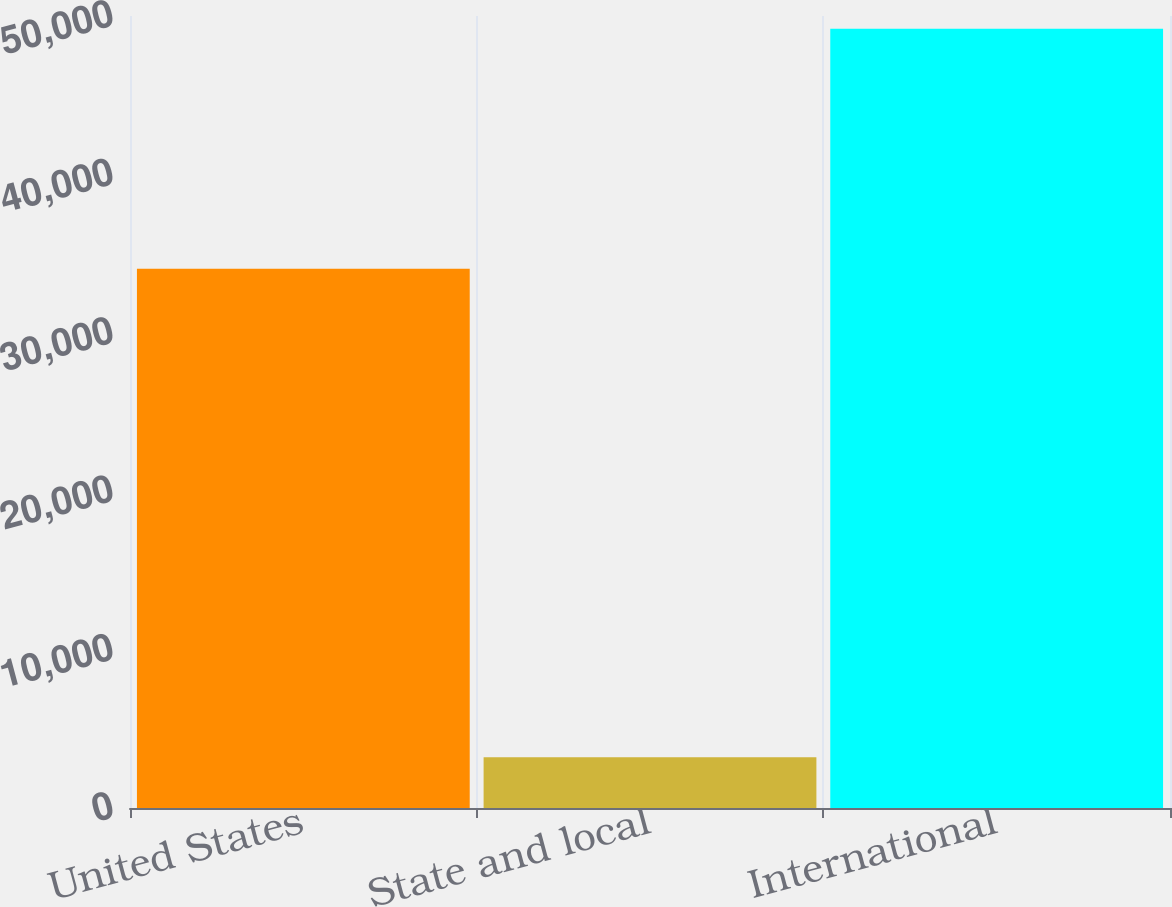Convert chart. <chart><loc_0><loc_0><loc_500><loc_500><bar_chart><fcel>United States<fcel>State and local<fcel>International<nl><fcel>34049<fcel>3203<fcel>49200<nl></chart> 